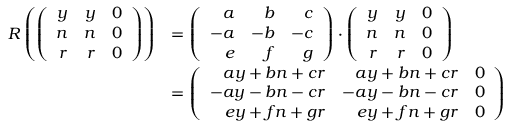Convert formula to latex. <formula><loc_0><loc_0><loc_500><loc_500>\begin{array} { r l } { R \left ( \left ( \begin{array} { r r r } { y } & { y } & { 0 } \\ { n } & { n } & { 0 } \\ { r } & { r } & { 0 } \end{array} \right ) \right ) } & { = \left ( \begin{array} { r r r } { a } & { b } & { c } \\ { - a } & { - b } & { - c } \\ { e } & { f } & { g } \end{array} \right ) \cdot \left ( \begin{array} { r r r } { y } & { y } & { 0 } \\ { n } & { n } & { 0 } \\ { r } & { r } & { 0 } \end{array} \right ) } \\ & { = \left ( \begin{array} { r r r } { a y + b n + c r } & { a y + b n + c r } & { 0 } \\ { - a y - b n - c r } & { - a y - b n - c r } & { 0 } \\ { e y + f n + g r } & { e y + f n + g r } & { 0 } \end{array} \right ) } \end{array}</formula> 